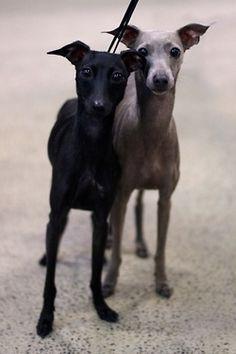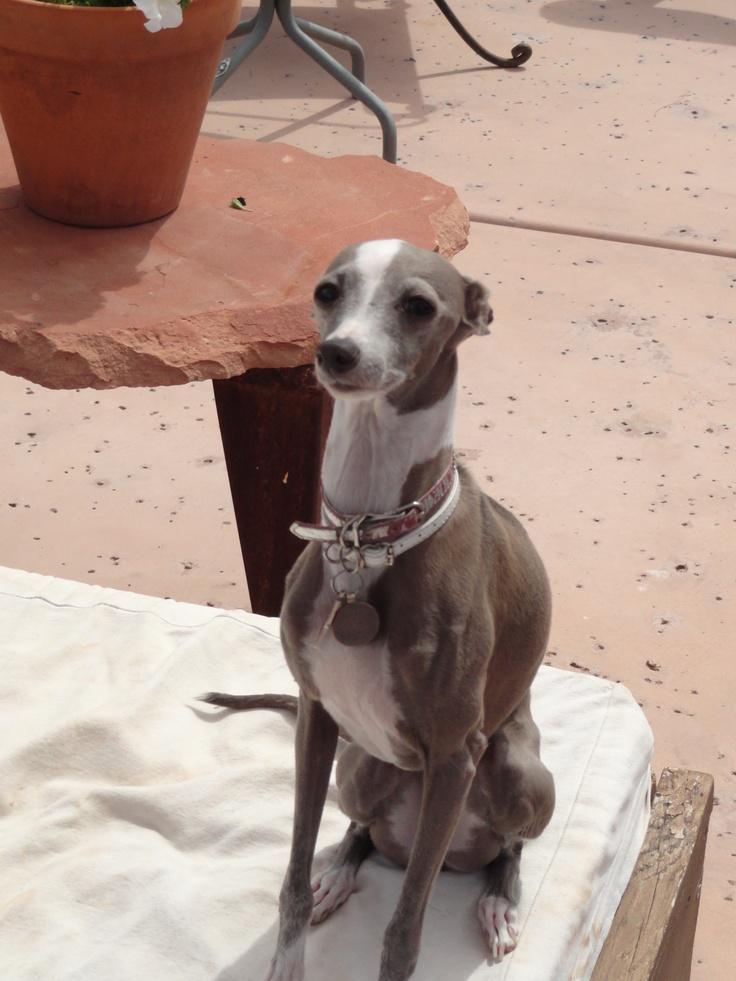The first image is the image on the left, the second image is the image on the right. Considering the images on both sides, is "An image contains two solid-colored hound dogs." valid? Answer yes or no. Yes. The first image is the image on the left, the second image is the image on the right. Considering the images on both sides, is "Two dogs pose together in one of the pictures." valid? Answer yes or no. Yes. 